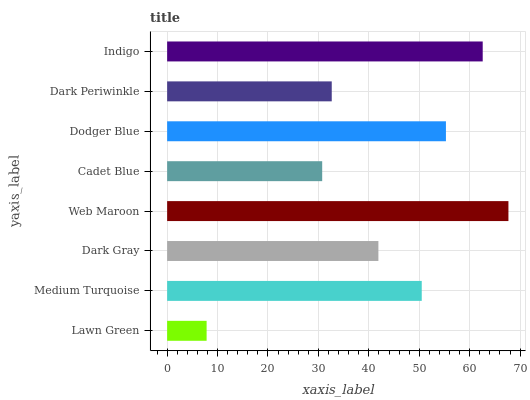Is Lawn Green the minimum?
Answer yes or no. Yes. Is Web Maroon the maximum?
Answer yes or no. Yes. Is Medium Turquoise the minimum?
Answer yes or no. No. Is Medium Turquoise the maximum?
Answer yes or no. No. Is Medium Turquoise greater than Lawn Green?
Answer yes or no. Yes. Is Lawn Green less than Medium Turquoise?
Answer yes or no. Yes. Is Lawn Green greater than Medium Turquoise?
Answer yes or no. No. Is Medium Turquoise less than Lawn Green?
Answer yes or no. No. Is Medium Turquoise the high median?
Answer yes or no. Yes. Is Dark Gray the low median?
Answer yes or no. Yes. Is Indigo the high median?
Answer yes or no. No. Is Web Maroon the low median?
Answer yes or no. No. 